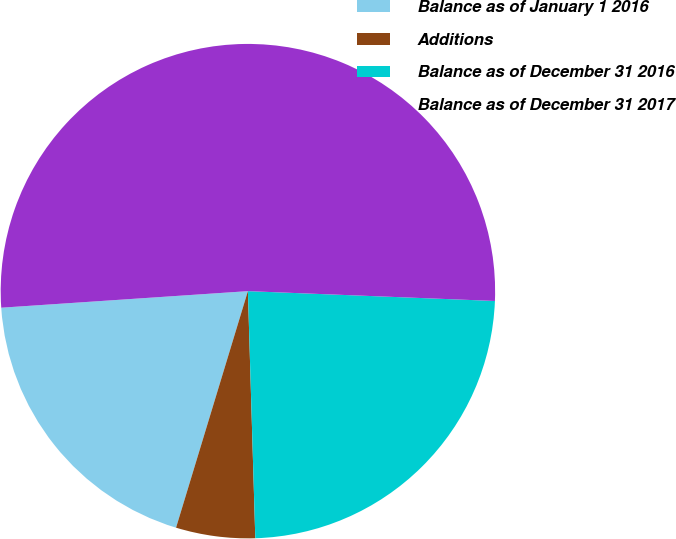Convert chart to OTSL. <chart><loc_0><loc_0><loc_500><loc_500><pie_chart><fcel>Balance as of January 1 2016<fcel>Additions<fcel>Balance as of December 31 2016<fcel>Balance as of December 31 2017<nl><fcel>19.24%<fcel>5.17%<fcel>23.89%<fcel>51.7%<nl></chart> 